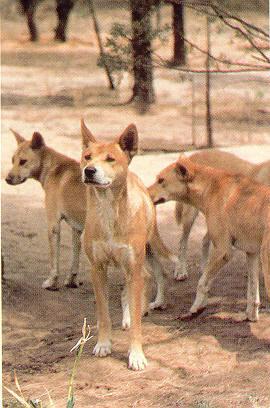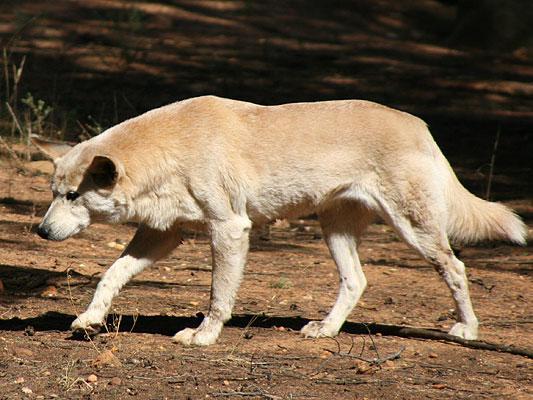The first image is the image on the left, the second image is the image on the right. Given the left and right images, does the statement "The left image includes exactly twice as many wild dogs as the right image." hold true? Answer yes or no. No. The first image is the image on the left, the second image is the image on the right. Examine the images to the left and right. Is the description "At least one animal is lying down in one of the images." accurate? Answer yes or no. No. 